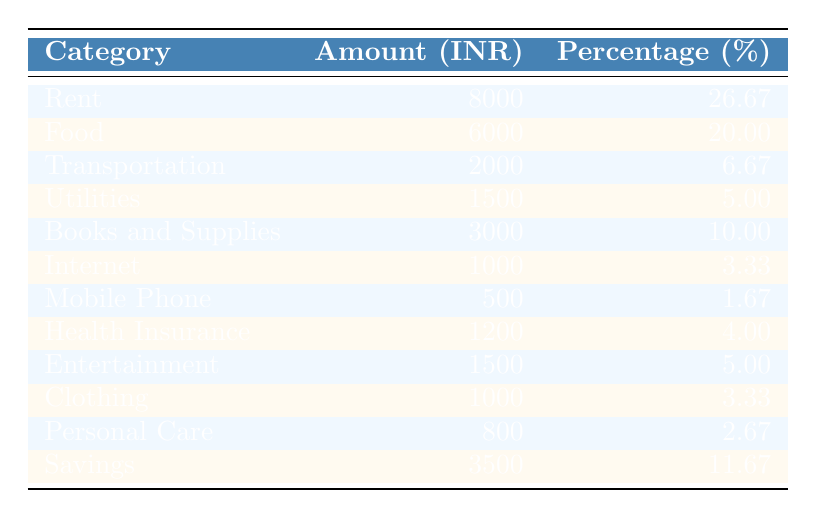What is the total amount spent on Rent and Food? The amount spent on Rent is 8000 INR and on Food is 6000 INR. Adding these two amounts gives: 8000 + 6000 = 14000 INR.
Answer: 14000 INR What category represents the highest percentage of monthly expenses? The highest percentage in the table is for Rent, which is 26.67%.
Answer: Rent What is the total percentage spent on Utilities and Internet? The percentage for Utilities is 5.00% and for Internet is 3.33%. Adding these two percentages yields: 5.00 + 3.33 = 8.33%.
Answer: 8.33% Is the amount spent on Health Insurance greater than that spent on Mobile Phone? The amount for Health Insurance is 1200 INR and for Mobile Phone is 500 INR. Since 1200 INR is greater than 500 INR, the statement is true.
Answer: Yes How much more is spent on Food compared to Transportation? The amount spent on Food is 6000 INR and on Transportation is 2000 INR. The difference is 6000 - 2000 = 4000 INR.
Answer: 4000 INR What percentage of total expenses does Clothing represent? The amount for Clothing is 1000 INR, the total expenses can be calculated by summing all categories (8000 + 6000 + 2000 + 1500 + 3000 + 1000 + 500 + 1200 + 1500 + 1000 + 800 + 3500 = 30000 INR). The percentage for Clothing is calculated as (1000/30000) * 100 = 3.33%.
Answer: 3.33% What is the combined amount spent on Entertainment and Personal Care? The amount spent on Entertainment is 1500 INR and on Personal Care is 800 INR. The total for these two categories is 1500 + 800 = 2300 INR.
Answer: 2300 INR What fraction of the total expenses is allocated to Savings? The amount for Savings is 3500 INR. The total expenses are 30000 INR. The fraction is then 3500/30000, which simplifies to 7/60.
Answer: 7/60 Is the percentage spent on Transportation more than that on Mobile Phone? Transportation has a percentage of 6.67% and Mobile Phone has 1.67%. Since 6.67% is greater than 1.67%, the statement is true.
Answer: Yes What category shares the same percentage as Utilities? Utilities has a percentage of 5.00%. Looking through the table, Entertainment also has the same percentage of 5.00%.
Answer: Entertainment 